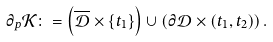Convert formula to latex. <formula><loc_0><loc_0><loc_500><loc_500>\partial _ { p } \mathcal { K } \colon = \left ( \overline { \mathcal { D } } \times \{ t _ { 1 } \} \right ) \cup \left ( \partial \mathcal { D } \times ( t _ { 1 } , t _ { 2 } ) \right ) .</formula> 